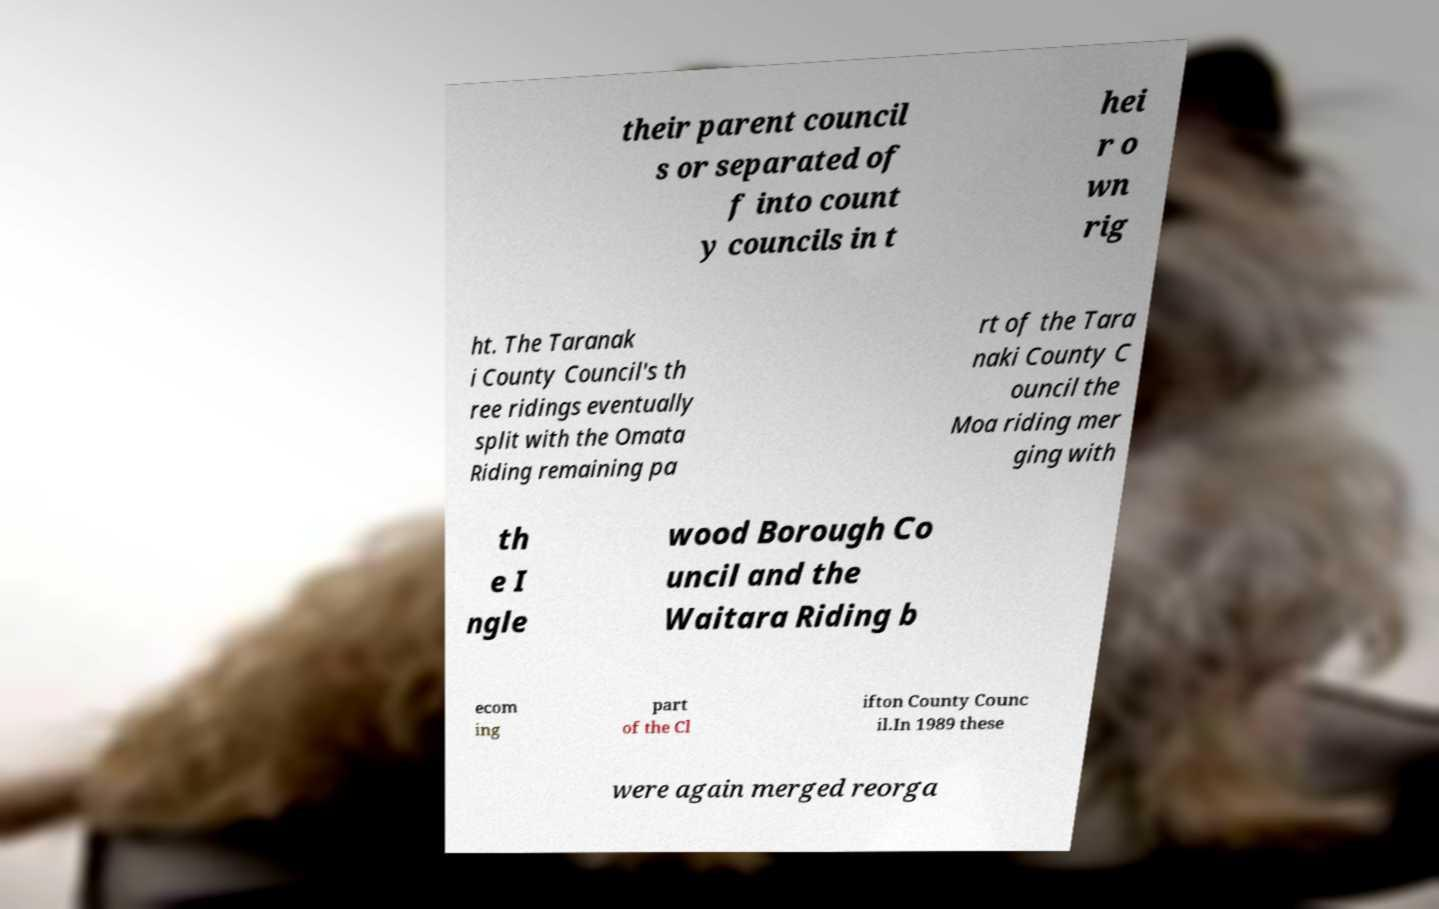There's text embedded in this image that I need extracted. Can you transcribe it verbatim? their parent council s or separated of f into count y councils in t hei r o wn rig ht. The Taranak i County Council's th ree ridings eventually split with the Omata Riding remaining pa rt of the Tara naki County C ouncil the Moa riding mer ging with th e I ngle wood Borough Co uncil and the Waitara Riding b ecom ing part of the Cl ifton County Counc il.In 1989 these were again merged reorga 